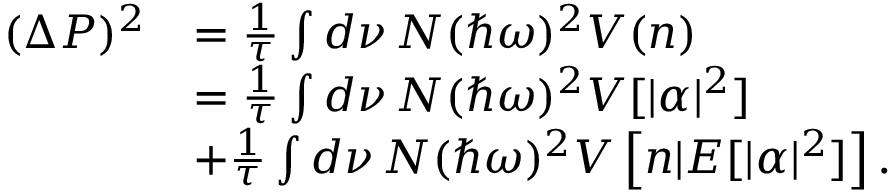Convert formula to latex. <formula><loc_0><loc_0><loc_500><loc_500>\begin{array} { r l } { ( \Delta P ) ^ { 2 } } & { = \frac { 1 } { \tau } \int d \nu \, N ( \hbar { \omega } ) ^ { 2 } V ( n ) } \\ & { = \frac { 1 } { \tau } \int d \nu \, N ( \hbar { \omega } ) ^ { 2 } V [ | \alpha | ^ { 2 } ] } \\ & { + \frac { 1 } { \tau } \int d \nu \, N ( \hbar { \omega } ) ^ { 2 } V \left [ n | E [ | \alpha | ^ { 2 } ] \right ] . } \end{array}</formula> 